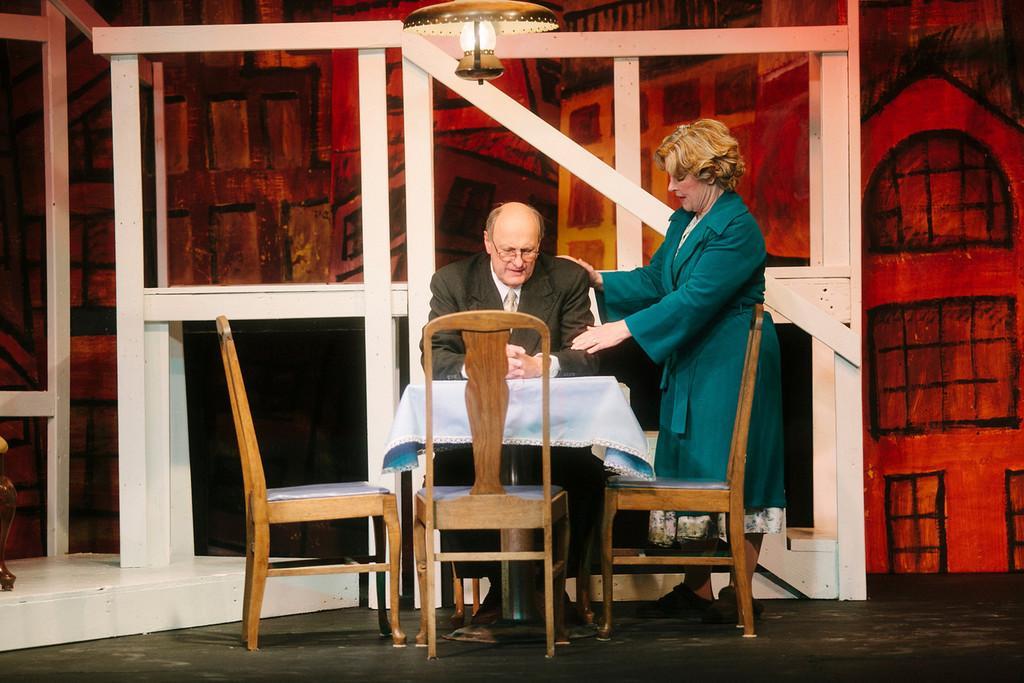How would you summarize this image in a sentence or two? In the given image we can see there are two person, man is sitting and woman is standing. There is a table and chairs. Above them there is a lamp. 